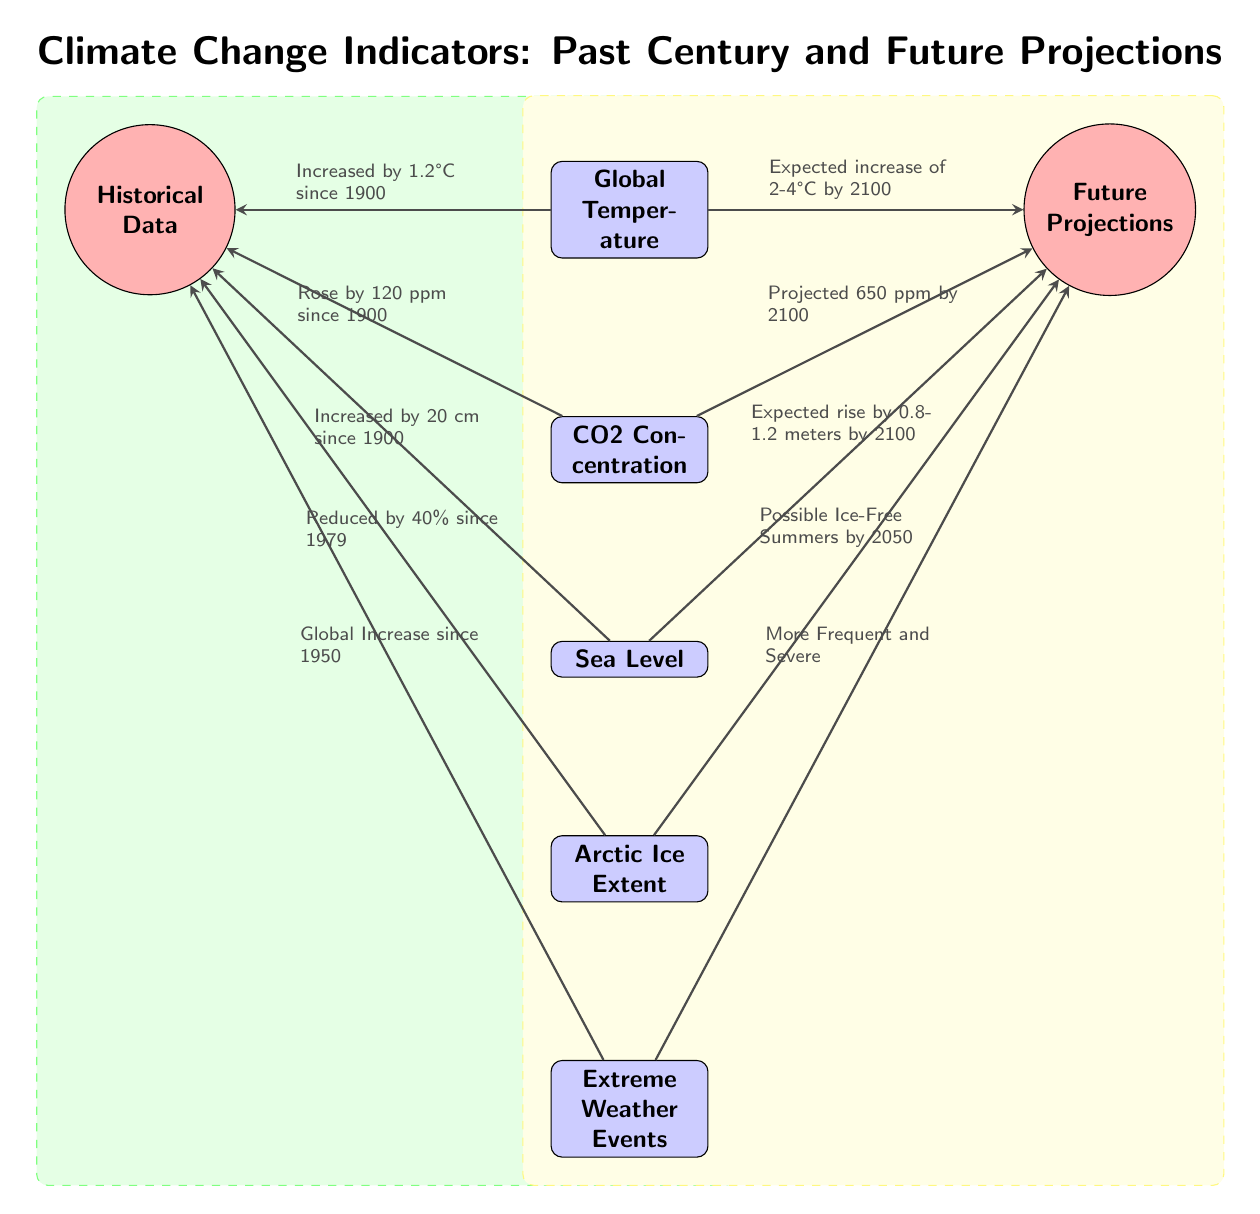What is the increase in global temperature since 1900? The diagram directly states that the global temperature has increased by 1.2°C since 1900. This information is clearly indicated in the connection from the global temperature node to the historical data period.
Answer: 1.2°C How much has CO2 concentration risen since 1900? The diagram indicates that CO2 concentration has risen by 120 ppm since 1900, as shown by the note associated with the CO2 concentration node linked to the historical data.
Answer: 120 ppm What is the expected sea level rise by 2100? According to the diagram, the expected rise in sea level by 2100 is indicated as being between 0.8 to 1.2 meters, connected from the sea level node to the future projections period.
Answer: 0.8-1.2 meters What percentage reduction in Arctic ice extent has occurred since 1979? The diagram notes a reduction of 40% in Arctic ice extent since 1979, which is connected to the historical data period. This percentage is crucial information displayed in this node.
Answer: 40% What is the projected CO2 concentration by 2100? The future projection node for CO2 concentration indicates a level of 650 ppm by 2100. This is clearly mentioned adjacent to the CO2 concentration indicator connected to future projections.
Answer: 650 ppm How many indicators are shown in the diagram? The diagram presents a total of five indicators: Global Temperature, CO2 Concentration, Sea Level, Arctic Ice Extent, and Extreme Weather Events, which are arranged vertically. This counting of nodes gives the total number of indicators represented.
Answer: 5 What is the expected temperature increase range by 2100? As the diagram indicates, the expected increase in global temperature by 2100 is projected to be between 2 to 4°C. This anticipated range is detailed in the node associated with the temperature indicator pointing to future projections.
Answer: 2-4°C What does the diagram suggest about extreme weather events since 1950? The diagram suggests that there has been a global increase in extreme weather events since 1950, which is linked to the extreme weather events indicator in the historical period.
Answer: Global Increase since 1950 What connects the historical data to the Arctic ice extent indicator? The connection between the historical data period and the Arctic ice extent indicator is represented by a note indicating the reduction of 40% since 1979. This is how the two nodes are linked in the diagram.
Answer: Reduction of 40% since 1979 